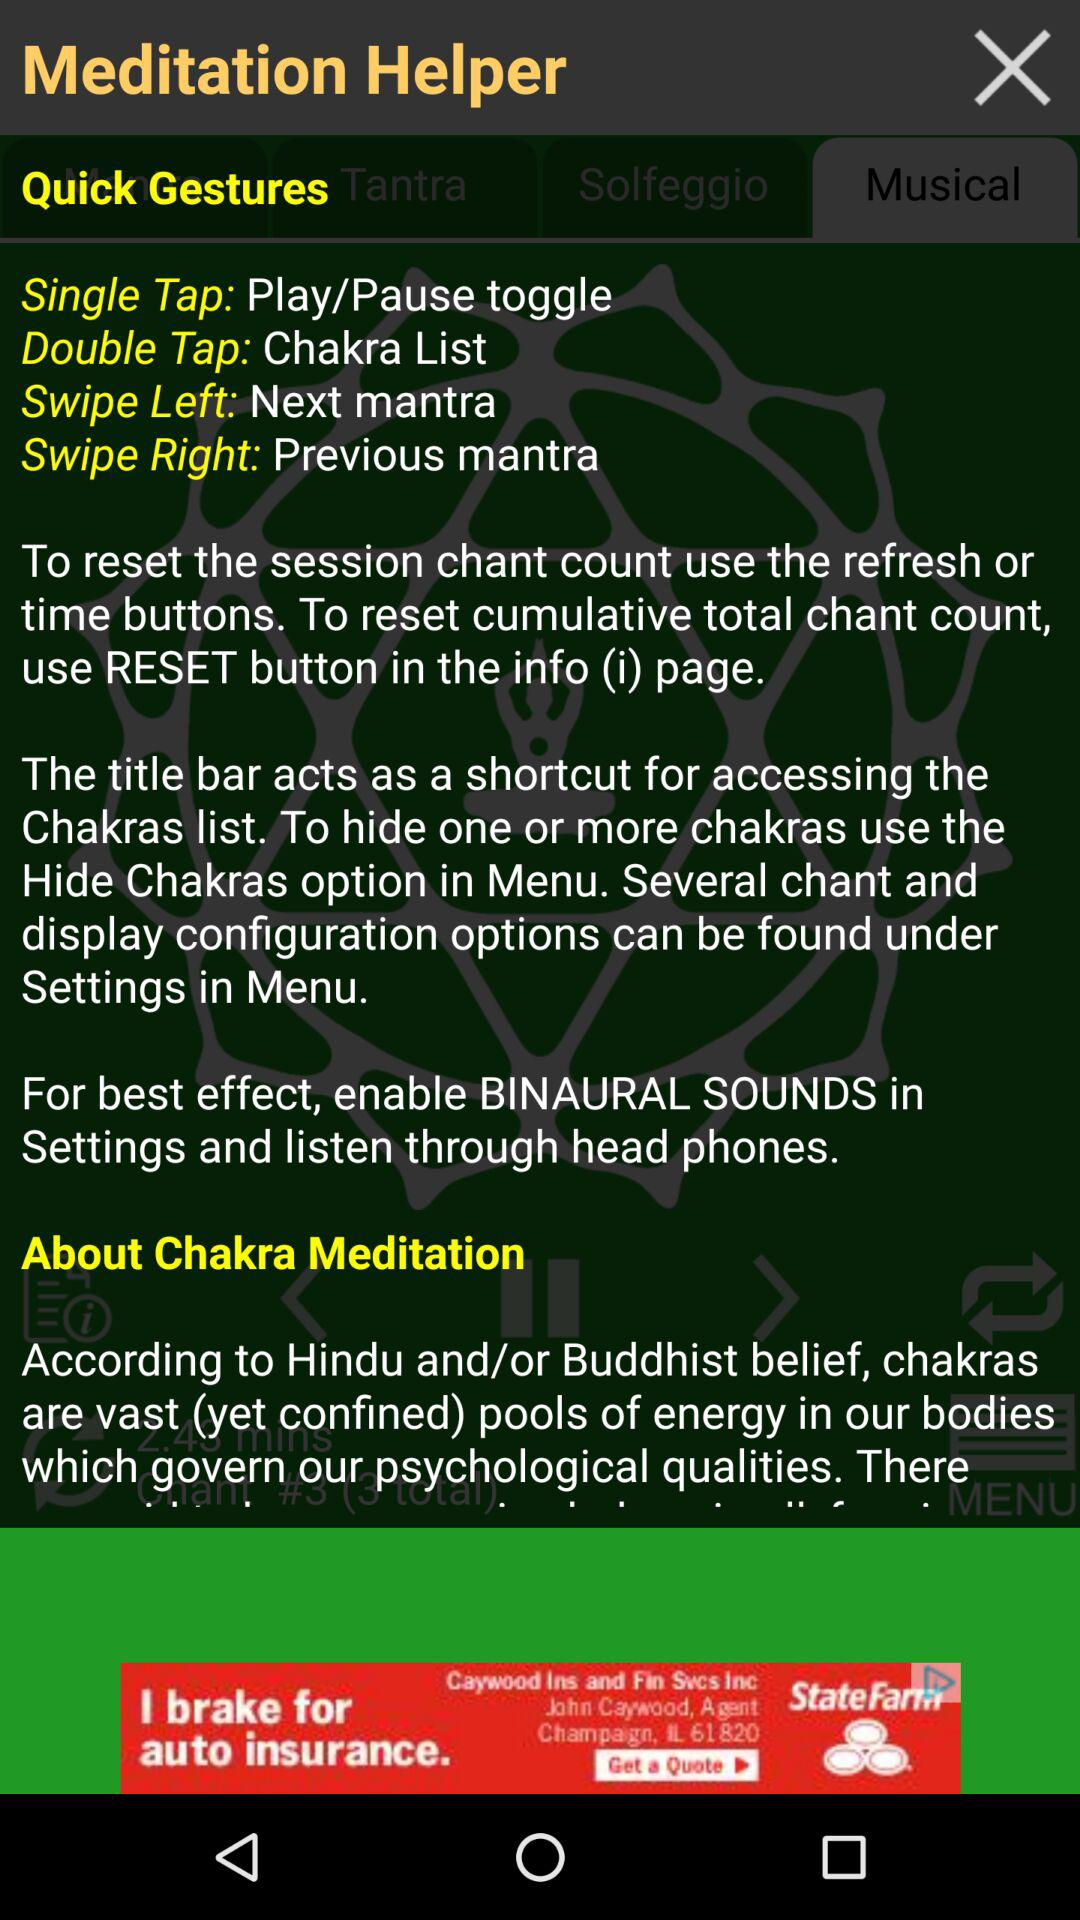How many taps are needed for the "Chakra List"? For the "Chakra List", double tap is needed. 